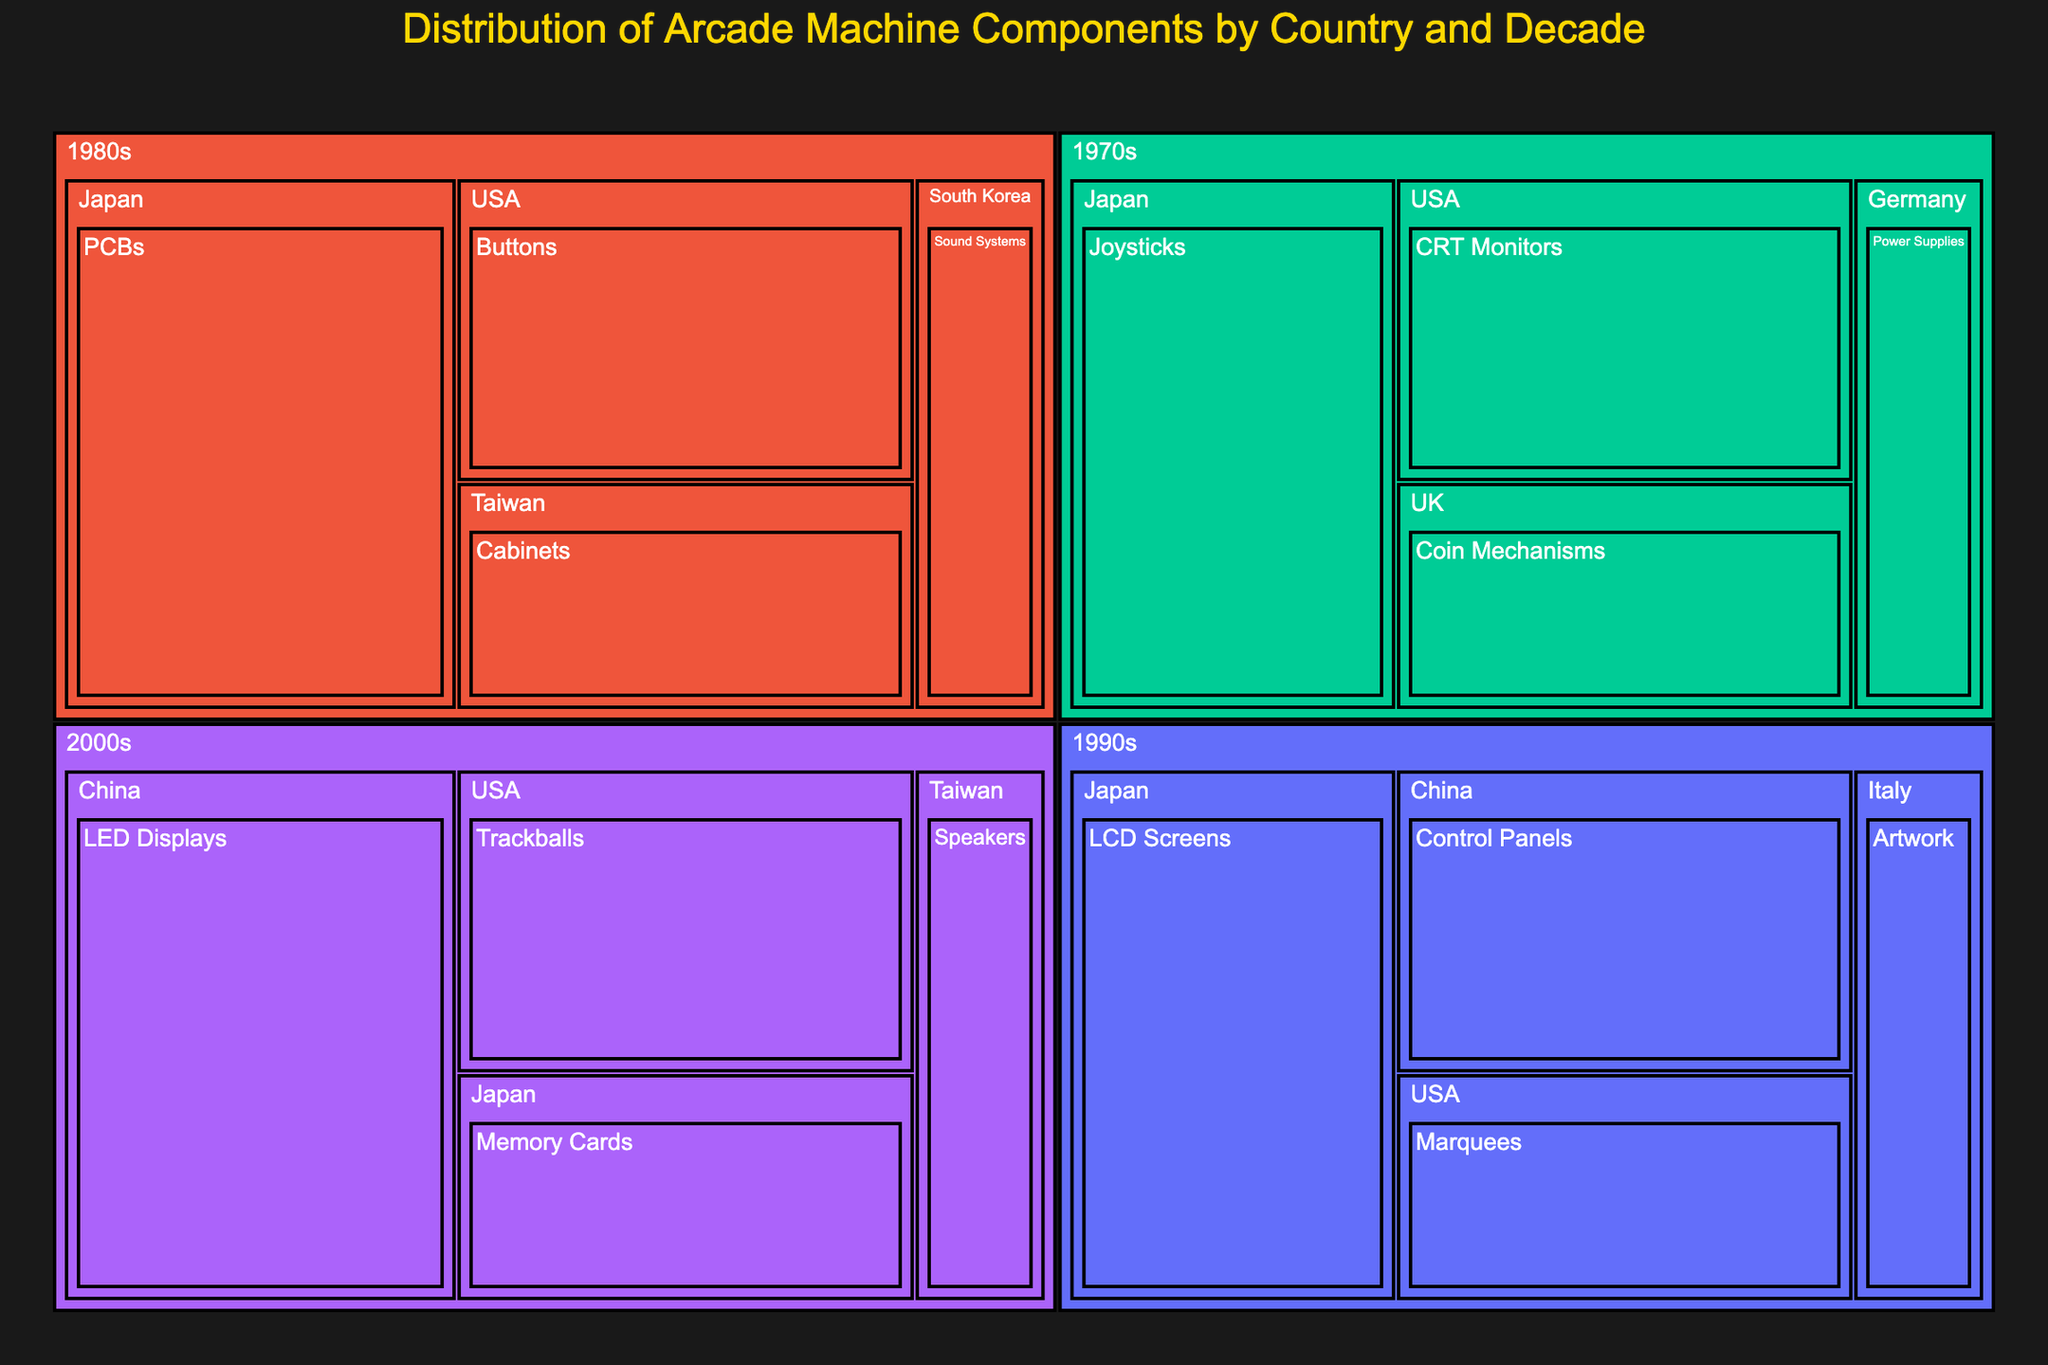What is the title of the treemap? The title is usually found at the top of the treemap and provides a summary of what the chart represents.
Answer: Distribution of Arcade Machine Components by Country and Decade Which decade contributed the most to the joystick components? Look for the "Joysticks" component in the treemap and identify the decade associated with it.
Answer: 1970s Which country has the largest percentage of arcade machine components in the 1980s? Find the section labeled "1980s" and identify which sub-section (country) has the largest area, indicating the highest percentage.
Answer: Japan Which component had the least percentage contribution from Germany in the 1970s? Within the "1970s" and "Germany" sections of the treemap, locate the component with the smallest area.
Answer: Power Supplies What is the total percentage contribution of Japanese components across all decades? Sum the percentage values of Japanese components for each decade.
Answer: 95 Between South Korea and Taiwan in the 1980s, which country contributed more to the arcade machine components, and by how much? In the "1980s" section, compare the percentages for "South Korea" and "Taiwan" and calculate the difference.
Answer: Taiwan, by 5% How does the contribution of LCD Screens in the 1990s compare to CRT Monitors in the 1970s? Identify the percentage values for "LCD Screens" in the 1990s and "CRT Monitors" in the 1970s and compare them.
Answer: LCD Screens contribute 5% more Which decade had the most diverse range of components, and how can you tell? Look at each decade and count the number of unique components listed. The decade with the highest count is the most diverse.
Answer: 1980s (4 components) From the 2000s, which country contributed to the trackball components and what was the percentage? Locate the "2000s" section, find the "Trackballs" component and note the associated country and percentage.
Answer: USA, 20 What is the average contribution percentage of the components from the USA across all decades? Identify all the components from the USA, sum their percentages, and divide by the number of components.
Answer: 18.75 